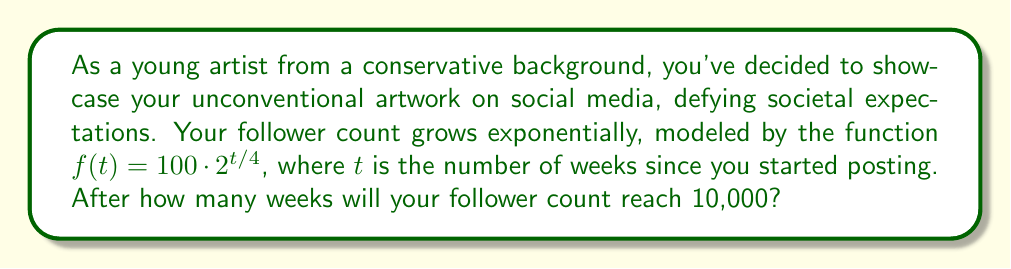Teach me how to tackle this problem. To solve this problem, we need to use logarithms to isolate the variable $t$. Let's approach this step-by-step:

1) We want to find $t$ when $f(t) = 10,000$. So, we set up the equation:

   $10,000 = 100 \cdot 2^{t/4}$

2) Divide both sides by 100:

   $100 = 2^{t/4}$

3) Now, we can apply the logarithm (base 2) to both sides:

   $\log_2(100) = \log_2(2^{t/4})$

4) Using the logarithm property $\log_a(a^x) = x$, we can simplify the right side:

   $\log_2(100) = \frac{t}{4}$

5) Multiply both sides by 4:

   $4 \log_2(100) = t$

6) We can calculate $\log_2(100)$ using the change of base formula:

   $\log_2(100) = \frac{\log(100)}{\log(2)} \approx 6.6439$

7) Therefore:

   $t = 4 \cdot 6.6439 \approx 26.5756$

Since we're dealing with whole weeks, we need to round up to the nearest whole number.
Answer: It will take 27 weeks for your follower count to reach 10,000. 